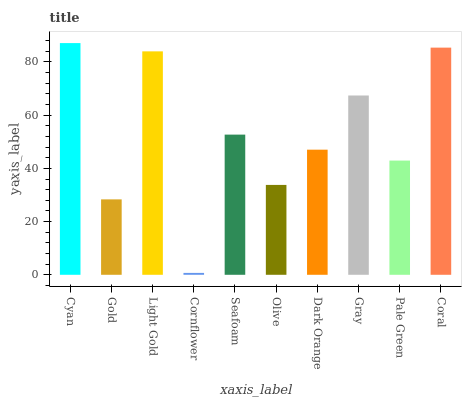Is Cornflower the minimum?
Answer yes or no. Yes. Is Cyan the maximum?
Answer yes or no. Yes. Is Gold the minimum?
Answer yes or no. No. Is Gold the maximum?
Answer yes or no. No. Is Cyan greater than Gold?
Answer yes or no. Yes. Is Gold less than Cyan?
Answer yes or no. Yes. Is Gold greater than Cyan?
Answer yes or no. No. Is Cyan less than Gold?
Answer yes or no. No. Is Seafoam the high median?
Answer yes or no. Yes. Is Dark Orange the low median?
Answer yes or no. Yes. Is Coral the high median?
Answer yes or no. No. Is Pale Green the low median?
Answer yes or no. No. 